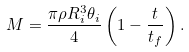Convert formula to latex. <formula><loc_0><loc_0><loc_500><loc_500>M = \frac { \pi \rho R _ { i } ^ { 3 } \theta _ { i } } 4 \left ( 1 - \frac { t } { t _ { f } } \right ) .</formula> 